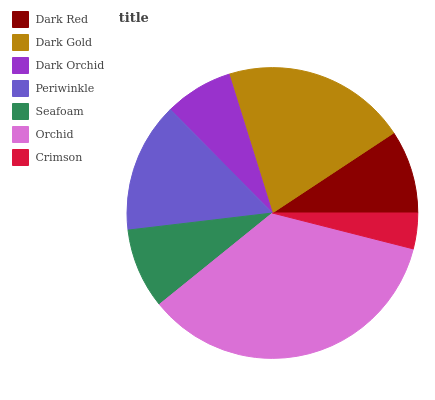Is Crimson the minimum?
Answer yes or no. Yes. Is Orchid the maximum?
Answer yes or no. Yes. Is Dark Gold the minimum?
Answer yes or no. No. Is Dark Gold the maximum?
Answer yes or no. No. Is Dark Gold greater than Dark Red?
Answer yes or no. Yes. Is Dark Red less than Dark Gold?
Answer yes or no. Yes. Is Dark Red greater than Dark Gold?
Answer yes or no. No. Is Dark Gold less than Dark Red?
Answer yes or no. No. Is Dark Red the high median?
Answer yes or no. Yes. Is Dark Red the low median?
Answer yes or no. Yes. Is Orchid the high median?
Answer yes or no. No. Is Crimson the low median?
Answer yes or no. No. 